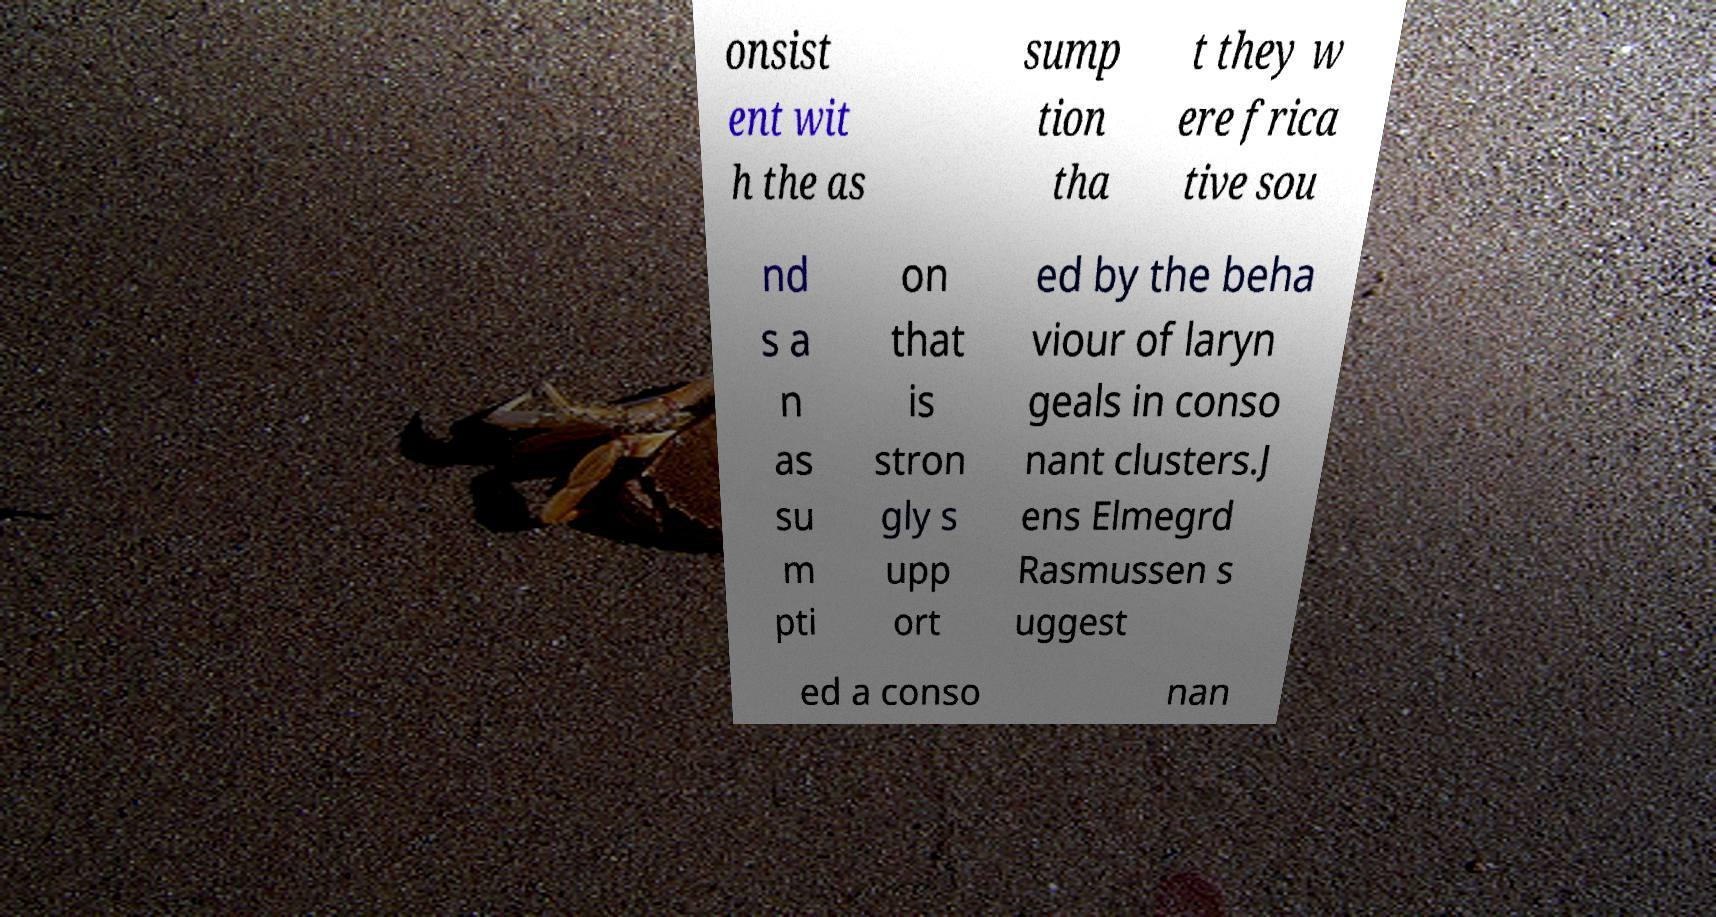For documentation purposes, I need the text within this image transcribed. Could you provide that? onsist ent wit h the as sump tion tha t they w ere frica tive sou nd s a n as su m pti on that is stron gly s upp ort ed by the beha viour of laryn geals in conso nant clusters.J ens Elmegrd Rasmussen s uggest ed a conso nan 